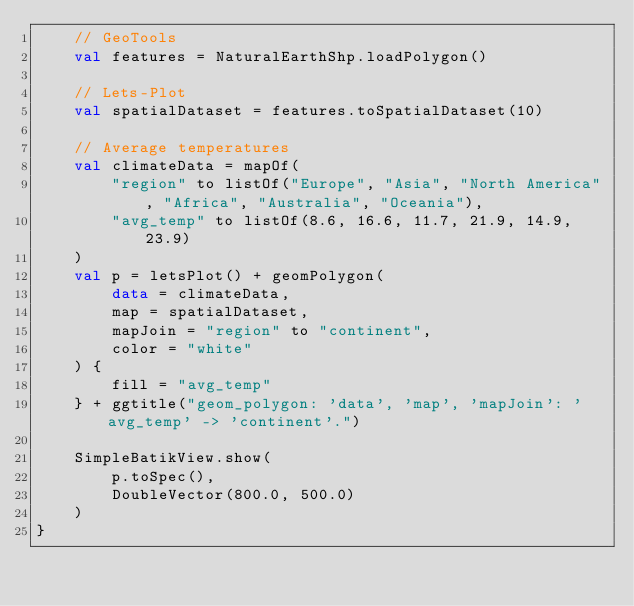Convert code to text. <code><loc_0><loc_0><loc_500><loc_500><_Kotlin_>    // GeoTools
    val features = NaturalEarthShp.loadPolygon()

    // Lets-Plot
    val spatialDataset = features.toSpatialDataset(10)

    // Average temperatures
    val climateData = mapOf(
        "region" to listOf("Europe", "Asia", "North America", "Africa", "Australia", "Oceania"),
        "avg_temp" to listOf(8.6, 16.6, 11.7, 21.9, 14.9, 23.9)
    )
    val p = letsPlot() + geomPolygon(
        data = climateData,
        map = spatialDataset,
        mapJoin = "region" to "continent",
        color = "white"
    ) {
        fill = "avg_temp"
    } + ggtitle("geom_polygon: 'data', 'map', 'mapJoin': 'avg_temp' -> 'continent'.")

    SimpleBatikView.show(
        p.toSpec(),
        DoubleVector(800.0, 500.0)
    )
}
</code> 